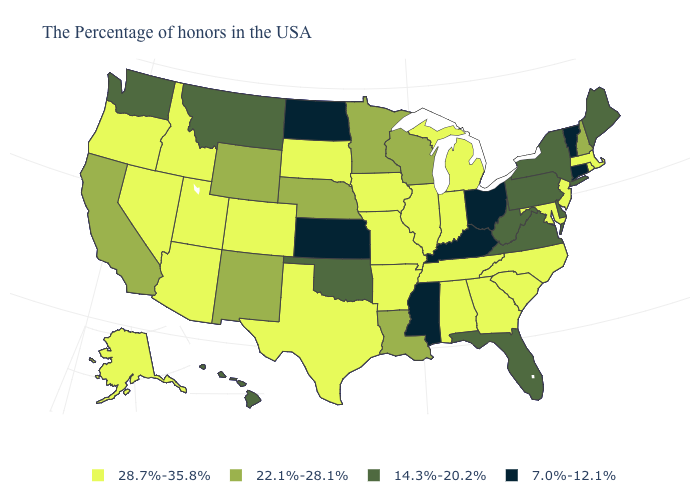What is the highest value in the USA?
Give a very brief answer. 28.7%-35.8%. Among the states that border New York , does Massachusetts have the highest value?
Quick response, please. Yes. Name the states that have a value in the range 28.7%-35.8%?
Be succinct. Massachusetts, Rhode Island, New Jersey, Maryland, North Carolina, South Carolina, Georgia, Michigan, Indiana, Alabama, Tennessee, Illinois, Missouri, Arkansas, Iowa, Texas, South Dakota, Colorado, Utah, Arizona, Idaho, Nevada, Oregon, Alaska. Does the first symbol in the legend represent the smallest category?
Short answer required. No. What is the lowest value in the USA?
Write a very short answer. 7.0%-12.1%. Does Indiana have the highest value in the MidWest?
Answer briefly. Yes. Does California have the highest value in the West?
Concise answer only. No. Among the states that border West Virginia , does Kentucky have the lowest value?
Write a very short answer. Yes. Does Alabama have the same value as Illinois?
Be succinct. Yes. Does Hawaii have the lowest value in the West?
Short answer required. Yes. Does Massachusetts have the highest value in the USA?
Quick response, please. Yes. Among the states that border Maryland , which have the highest value?
Keep it brief. Delaware, Pennsylvania, Virginia, West Virginia. Does Wyoming have the same value as Louisiana?
Be succinct. Yes. What is the value of Oklahoma?
Be succinct. 14.3%-20.2%. What is the value of Tennessee?
Give a very brief answer. 28.7%-35.8%. 